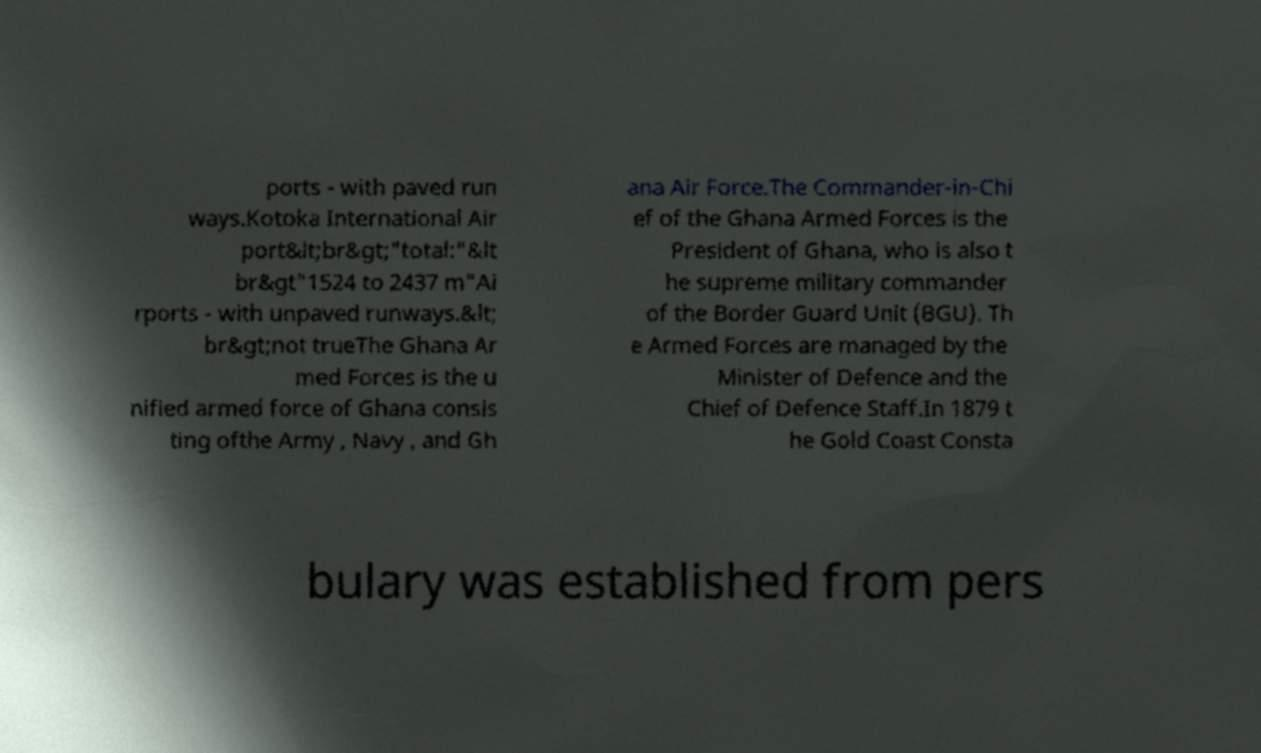For documentation purposes, I need the text within this image transcribed. Could you provide that? ports - with paved run ways.Kotoka International Air port&lt;br&gt;"total:"&lt br&gt"1524 to 2437 m"Ai rports - with unpaved runways.&lt; br&gt;not trueThe Ghana Ar med Forces is the u nified armed force of Ghana consis ting ofthe Army , Navy , and Gh ana Air Force.The Commander-in-Chi ef of the Ghana Armed Forces is the President of Ghana, who is also t he supreme military commander of the Border Guard Unit (BGU). Th e Armed Forces are managed by the Minister of Defence and the Chief of Defence Staff.In 1879 t he Gold Coast Consta bulary was established from pers 